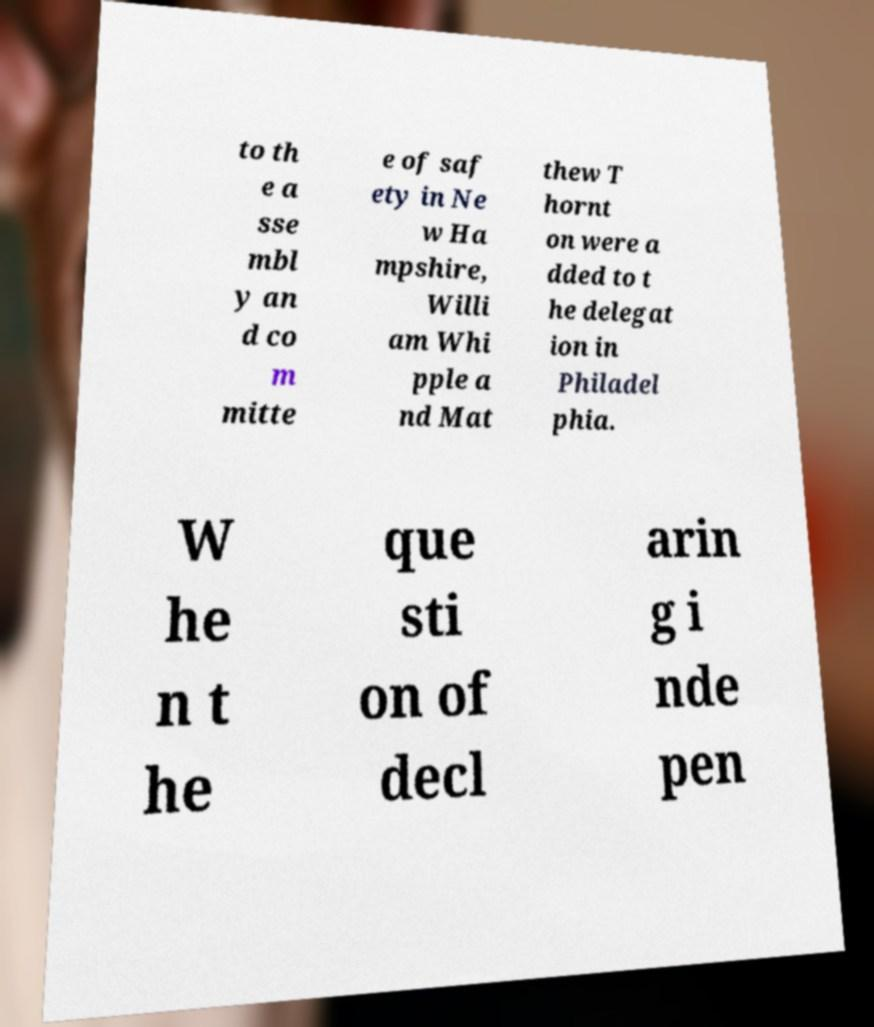What messages or text are displayed in this image? I need them in a readable, typed format. to th e a sse mbl y an d co m mitte e of saf ety in Ne w Ha mpshire, Willi am Whi pple a nd Mat thew T hornt on were a dded to t he delegat ion in Philadel phia. W he n t he que sti on of decl arin g i nde pen 